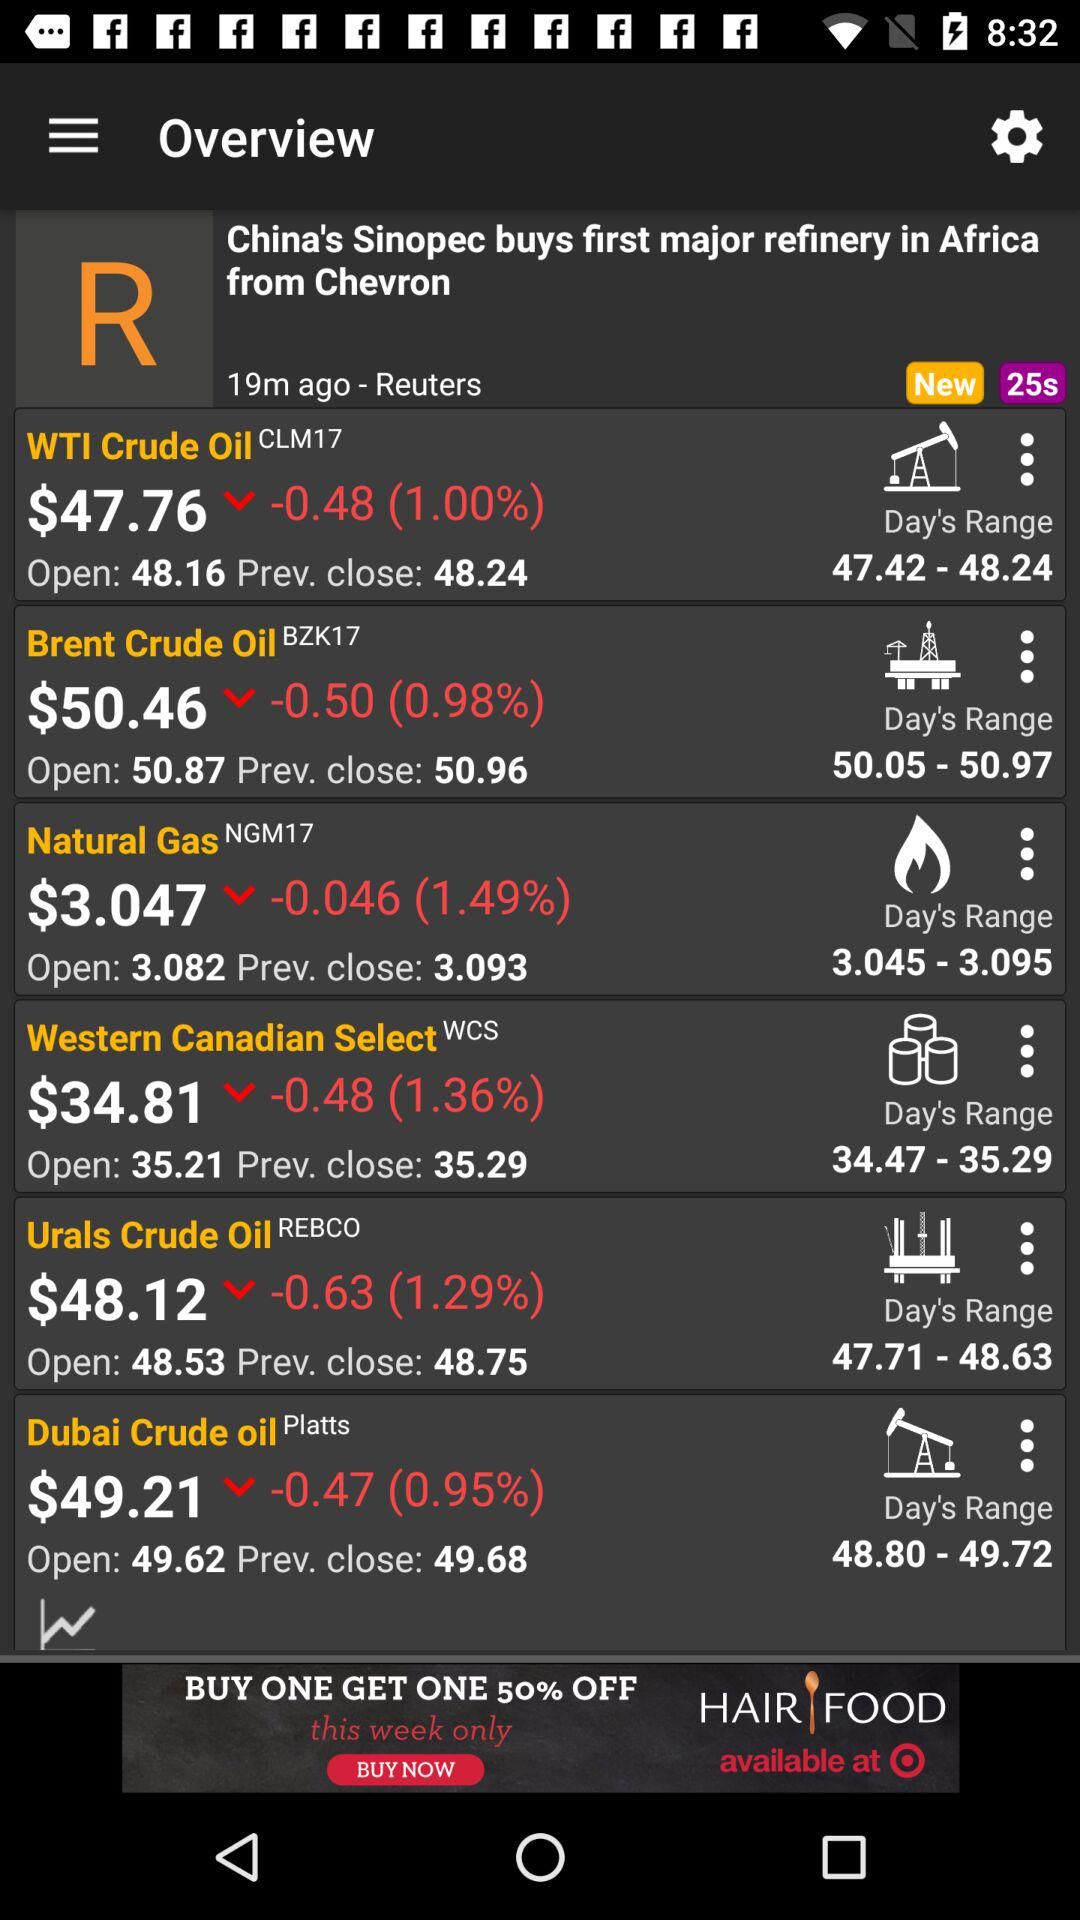Who shared this post? It is shared by "Reuters". 